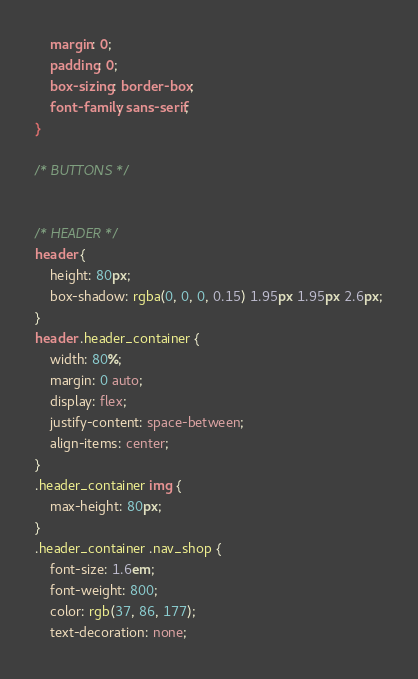Convert code to text. <code><loc_0><loc_0><loc_500><loc_500><_CSS_>    margin: 0;
    padding: 0;
    box-sizing: border-box;
    font-family: sans-serif;
}

/* BUTTONS */


/* HEADER */
header {
    height: 80px;
    box-shadow: rgba(0, 0, 0, 0.15) 1.95px 1.95px 2.6px;
}
header .header_container {
    width: 80%;
    margin: 0 auto;
    display: flex;
    justify-content: space-between;
    align-items: center;
}
.header_container img {
    max-height: 80px;
}
.header_container .nav_shop {
    font-size: 1.6em;
    font-weight: 800;
    color: rgb(37, 86, 177);
    text-decoration: none;</code> 